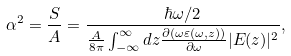Convert formula to latex. <formula><loc_0><loc_0><loc_500><loc_500>\alpha ^ { 2 } = \frac { S } { A } = \frac { \hbar { \omega } / 2 } { \frac { A } { 8 \pi } \int _ { - \infty } ^ { \infty } d z \frac { \partial ( \omega \varepsilon ( \omega , z ) ) } { \partial \omega } | E ( z ) | ^ { 2 } } ,</formula> 